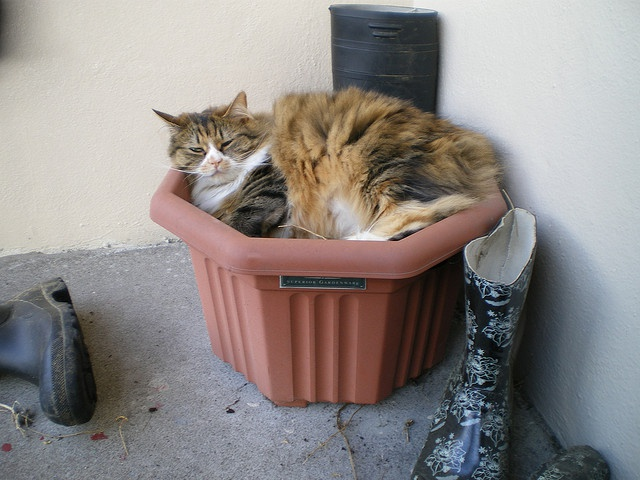Describe the objects in this image and their specific colors. I can see a cat in black, tan, and gray tones in this image. 